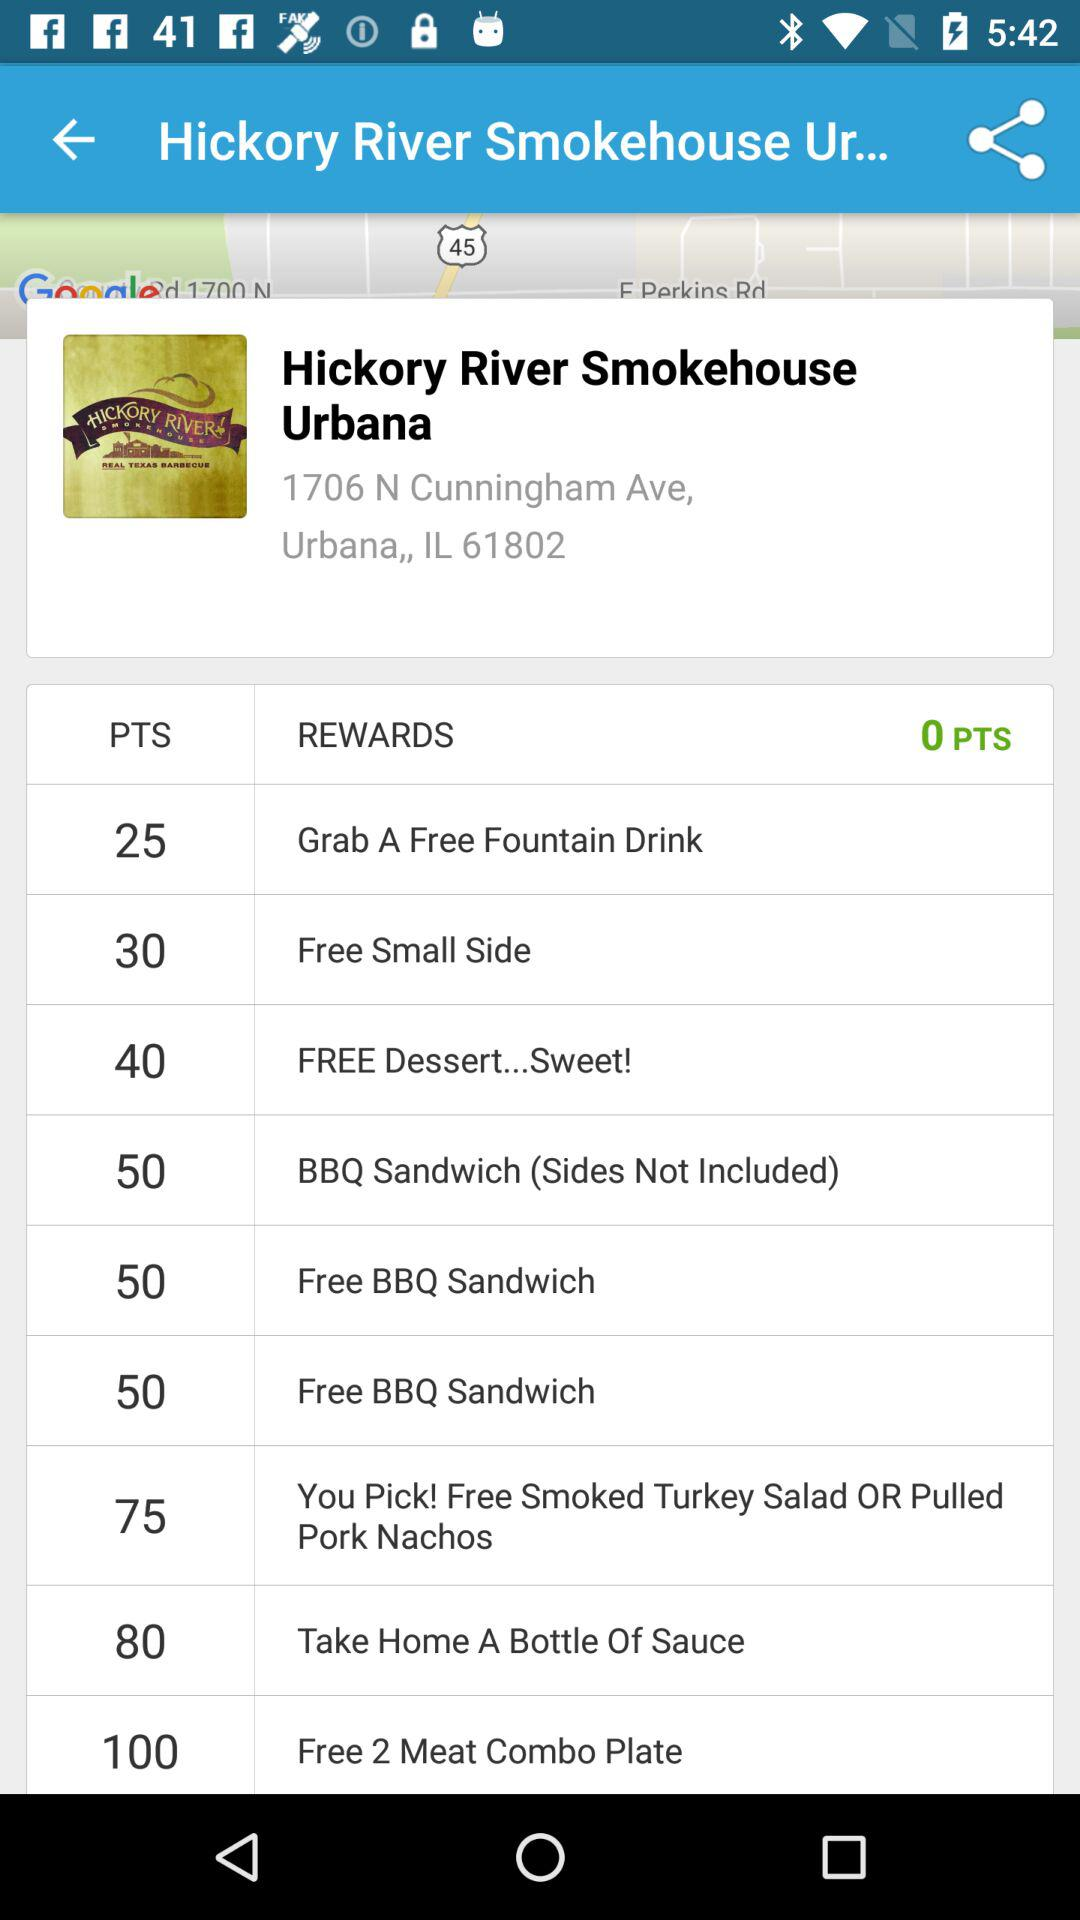What is the total points for a reward named "Free BBQ Sandwich"? The total points are 50. 